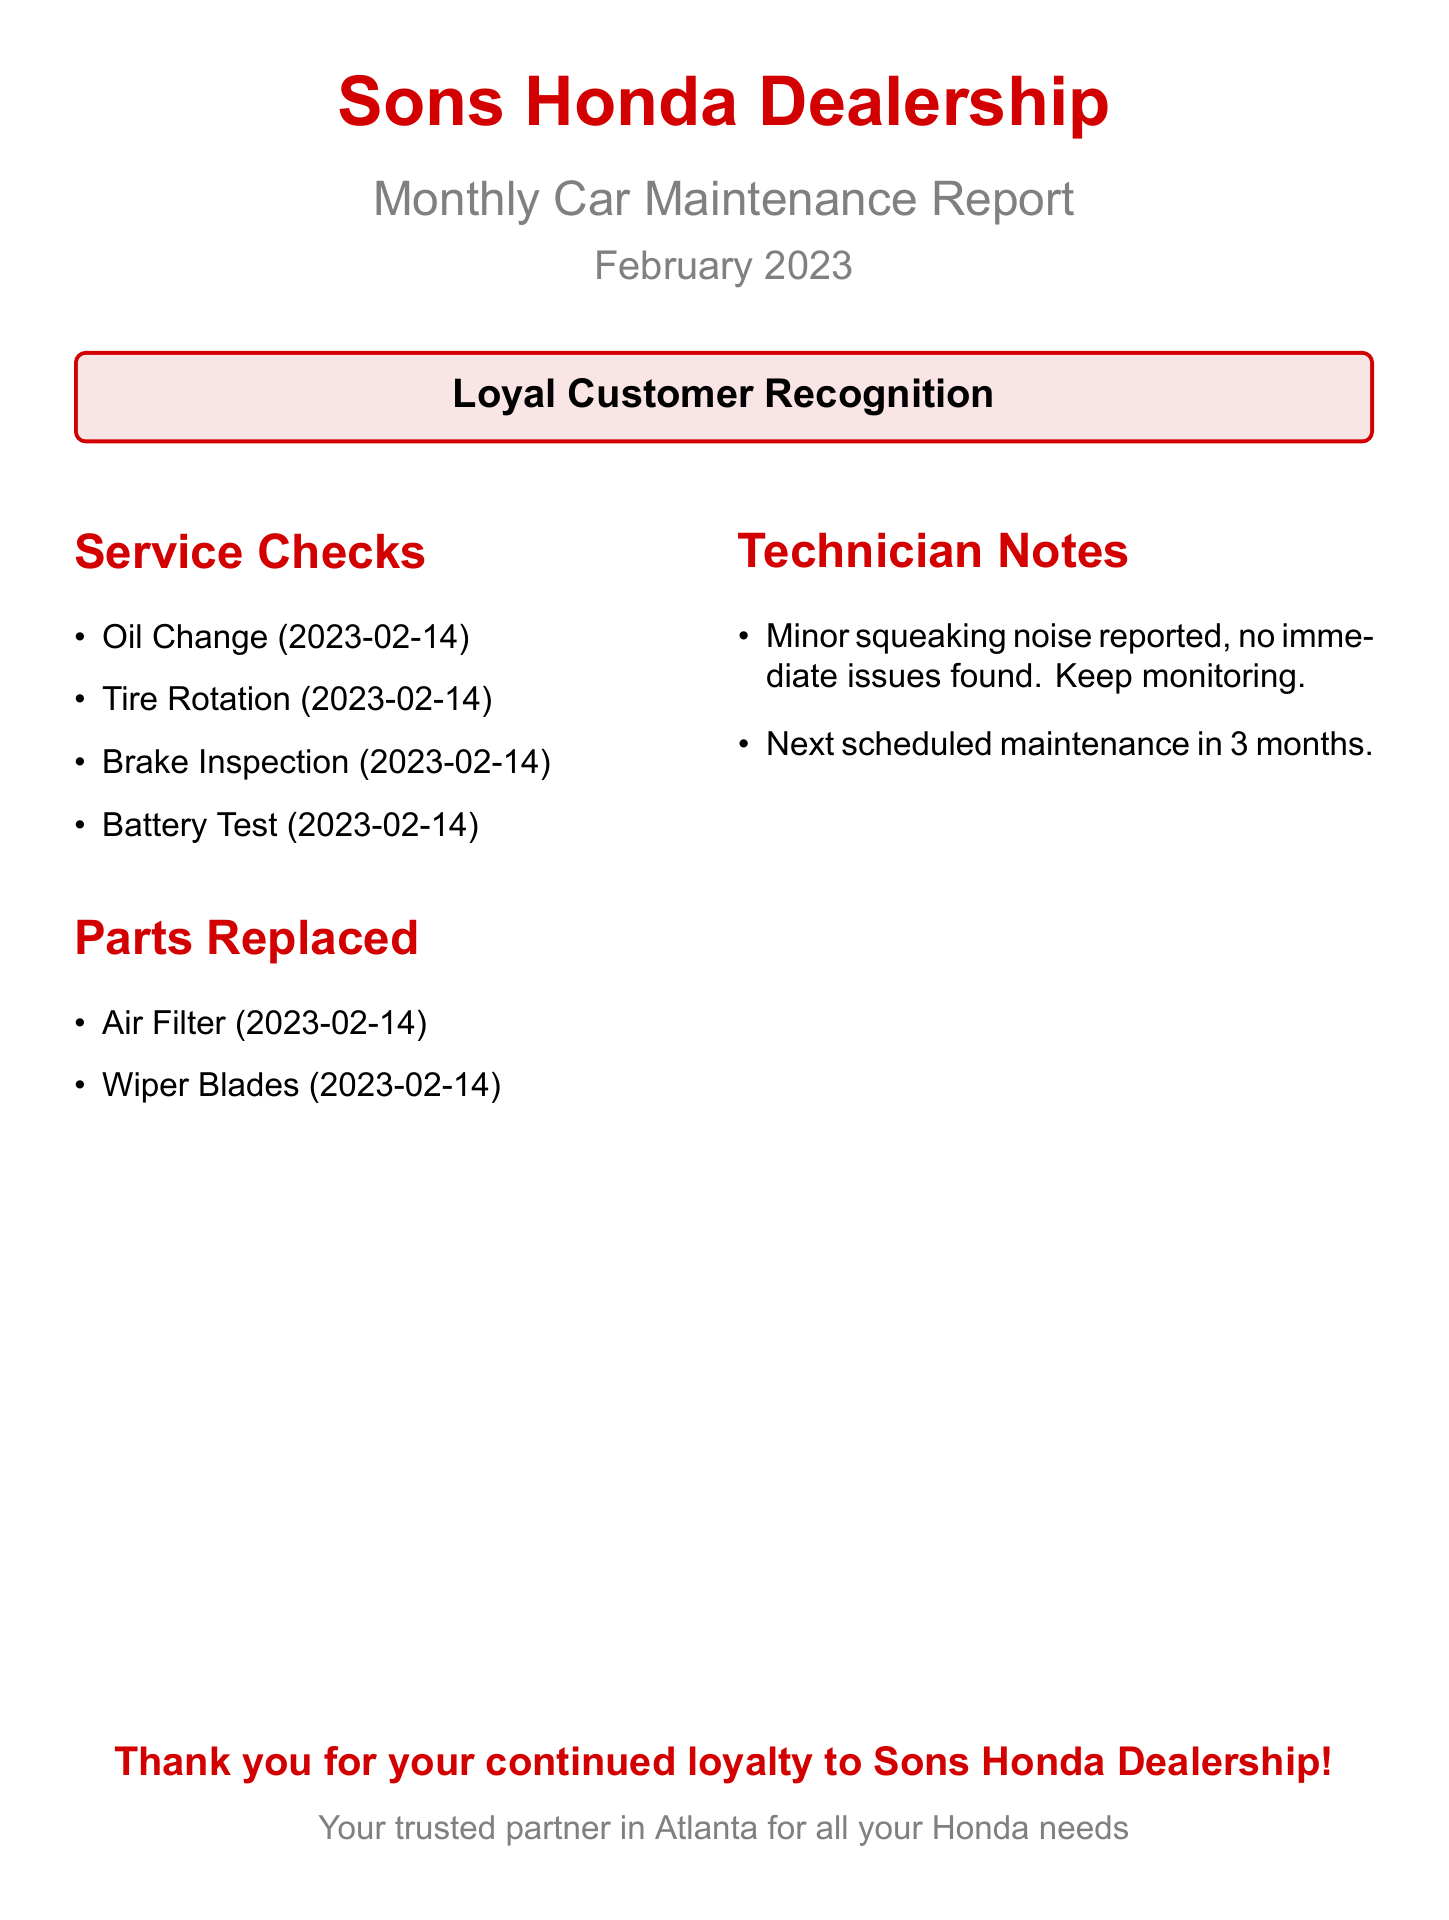what is the date of the oil change? The date of the oil change is listed in the service checks section.
Answer: 2023-02-14 how many parts were replaced in February 2023? The parts replaced are detailed in a list, which indicates two items were replaced.
Answer: 2 what type of inspection was done on February 14? The inspection types are listed under service checks, which includes the brake inspection.
Answer: Brake Inspection who is the document addressed to? The document includes a section thanking a specific group of customers for their loyalty.
Answer: Loyal Customer what is the color theme used for the dealership name? The color of the dealership name is specified in the document.
Answer: Hondared how often is the next scheduled maintenance? The technician notes specify the timeframe for the next scheduled maintenance.
Answer: 3 months what issue was reported during the maintenance? The technician notes mention a specific issue that was observed during the maintenance check.
Answer: Minor squeaking noise which parts were replaced on February 14? The replaced parts are listed under the parts replaced section.
Answer: Air Filter, Wiper Blades 